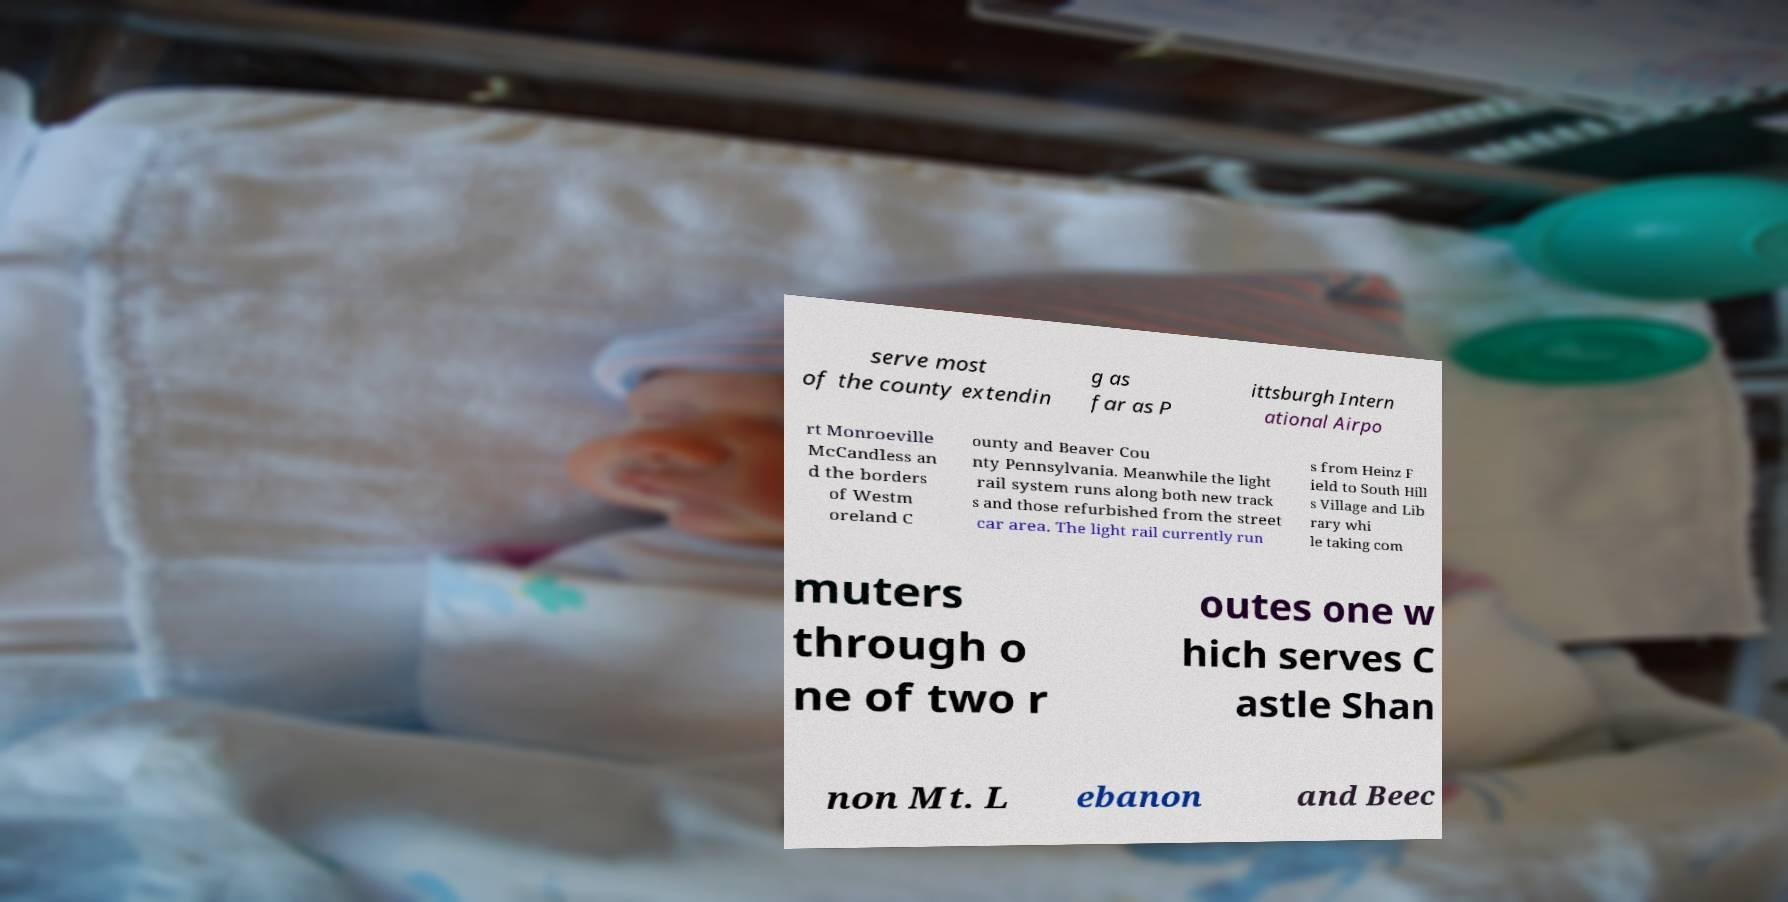Please identify and transcribe the text found in this image. serve most of the county extendin g as far as P ittsburgh Intern ational Airpo rt Monroeville McCandless an d the borders of Westm oreland C ounty and Beaver Cou nty Pennsylvania. Meanwhile the light rail system runs along both new track s and those refurbished from the street car area. The light rail currently run s from Heinz F ield to South Hill s Village and Lib rary whi le taking com muters through o ne of two r outes one w hich serves C astle Shan non Mt. L ebanon and Beec 